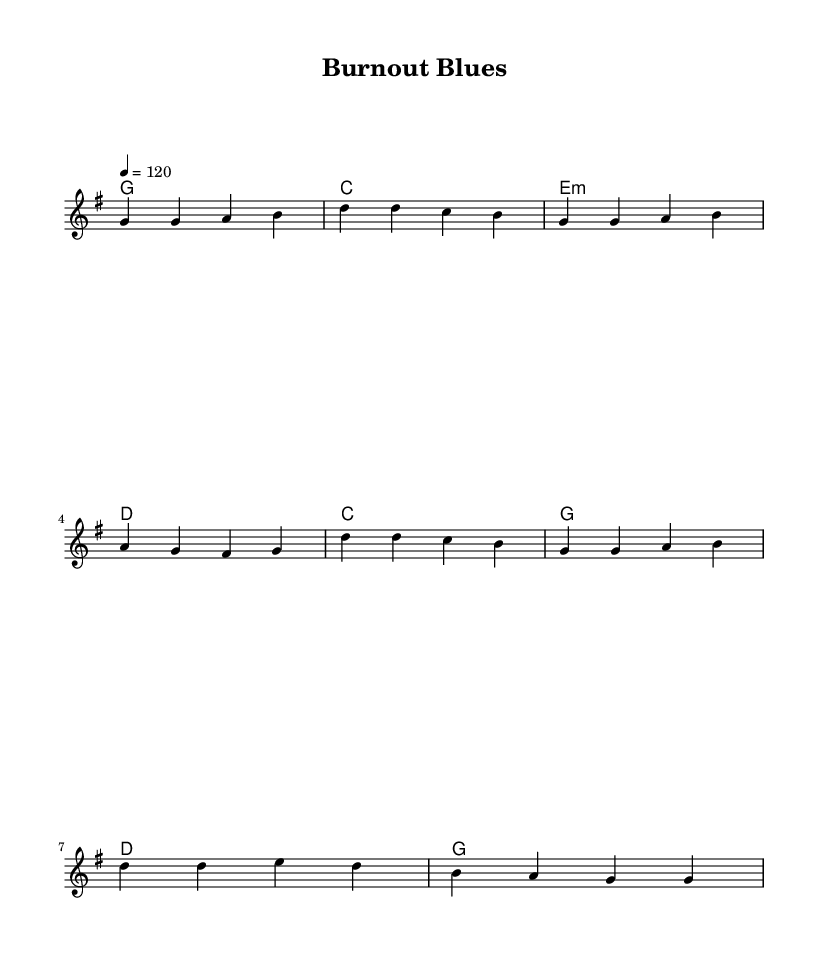What is the key signature of this music? The key signature shown at the beginning of the score indicates that there is one sharp, which corresponds to the key of G major.
Answer: G major What is the time signature of the piece? The time signature is found at the start of the score, indicating how many beats are in each measure. It shows 4/4, which means there are four beats per measure.
Answer: 4/4 What is the tempo of the piece? The tempo marking at the top indicates a speed of quarter note equals 120 beats per minute, meaning the piece should be played at a moderate pace.
Answer: 120 How many measures are in the verse section? The verse section can be counted from the noted melody lines and harmonies; there are four measures of lyrics in the verse.
Answer: Four measures What is the main theme of the lyrics described in the song? The lyrics focus on balancing the demands of work and personal life, emphasizing a struggle between career obligations and finding personal time.
Answer: Balancing work and personal life Which chord is played at the beginning of the verse? The first chord indicated in the harmonies section corresponds with the first note of the melody in the verse section, which is a G major chord.
Answer: G major 